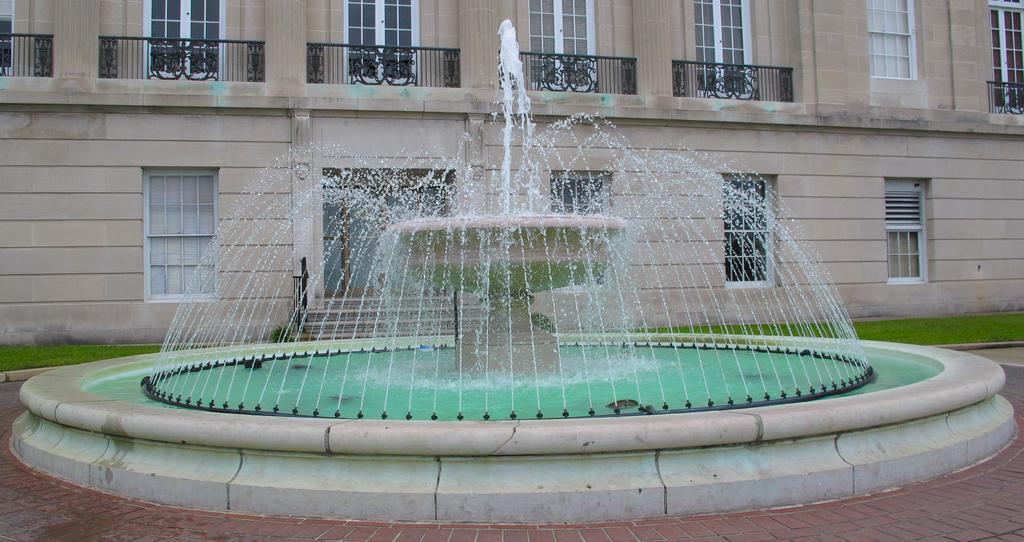Please provide a concise description of this image. In this image we can see a fountain and in the background, we can see a building, there are some windows, grille and grass on the ground. 